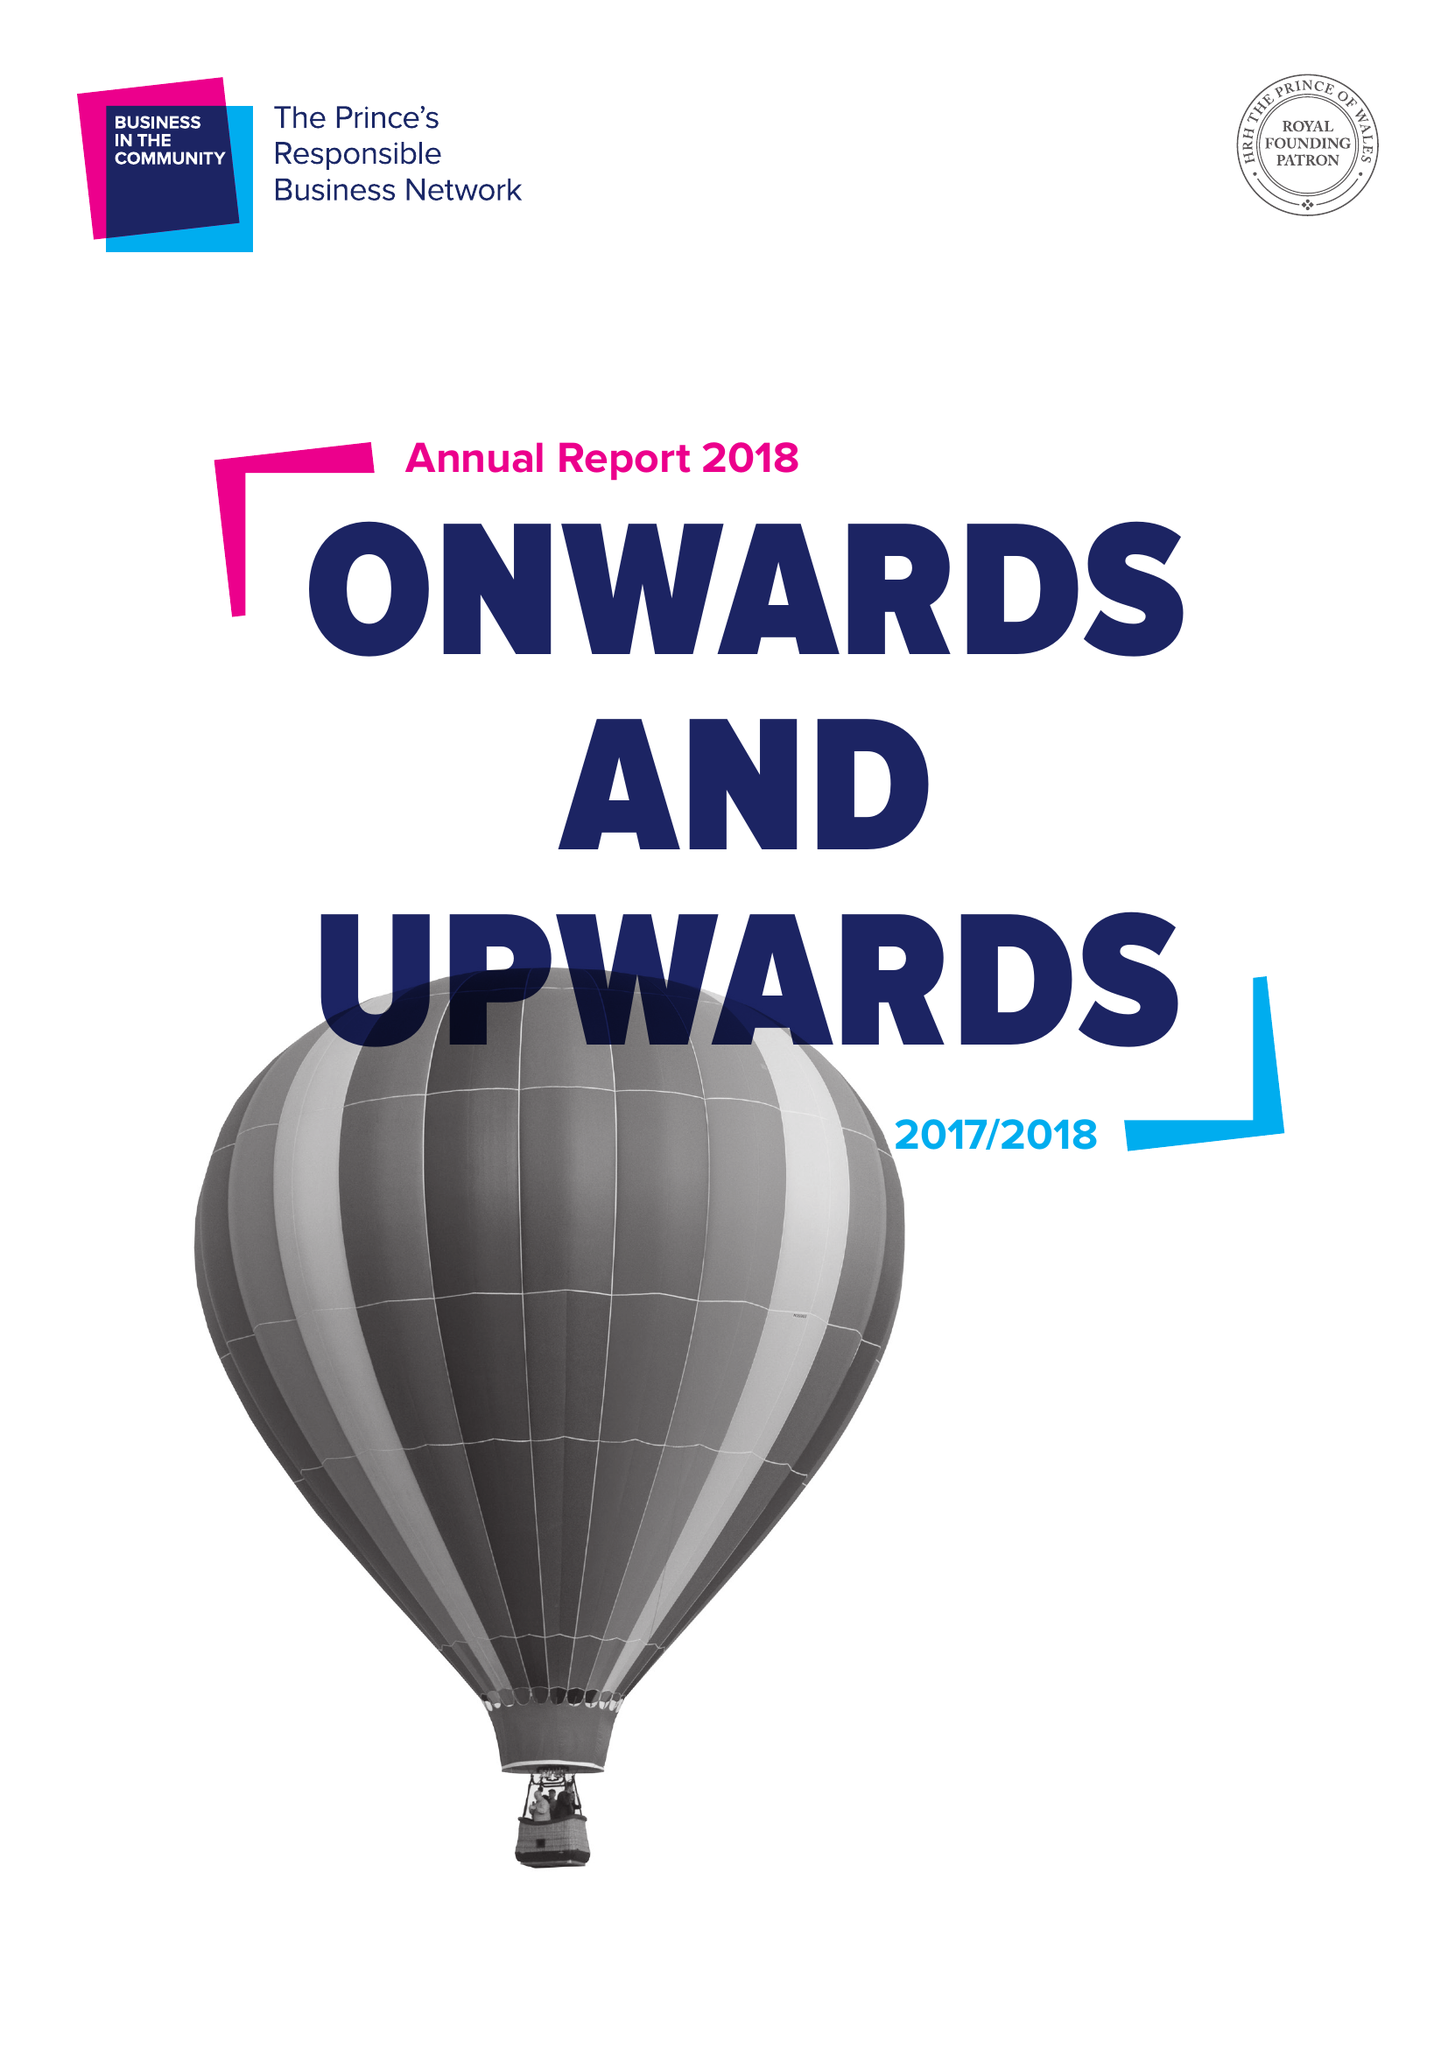What is the value for the income_annually_in_british_pounds?
Answer the question using a single word or phrase. 19846461.00 